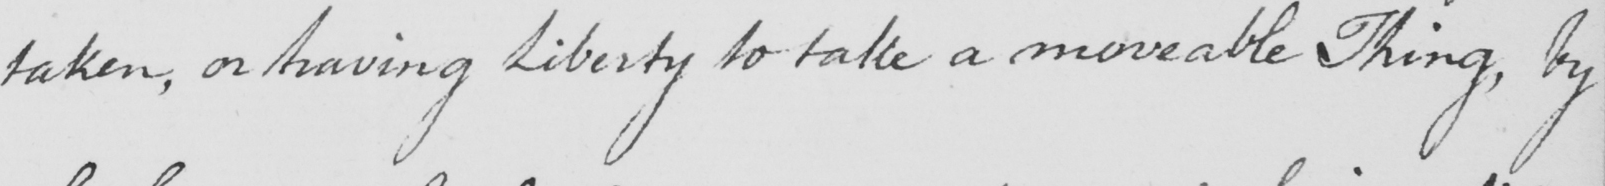Please provide the text content of this handwritten line. taken , on having Liberty to take a moveable Thing , by 